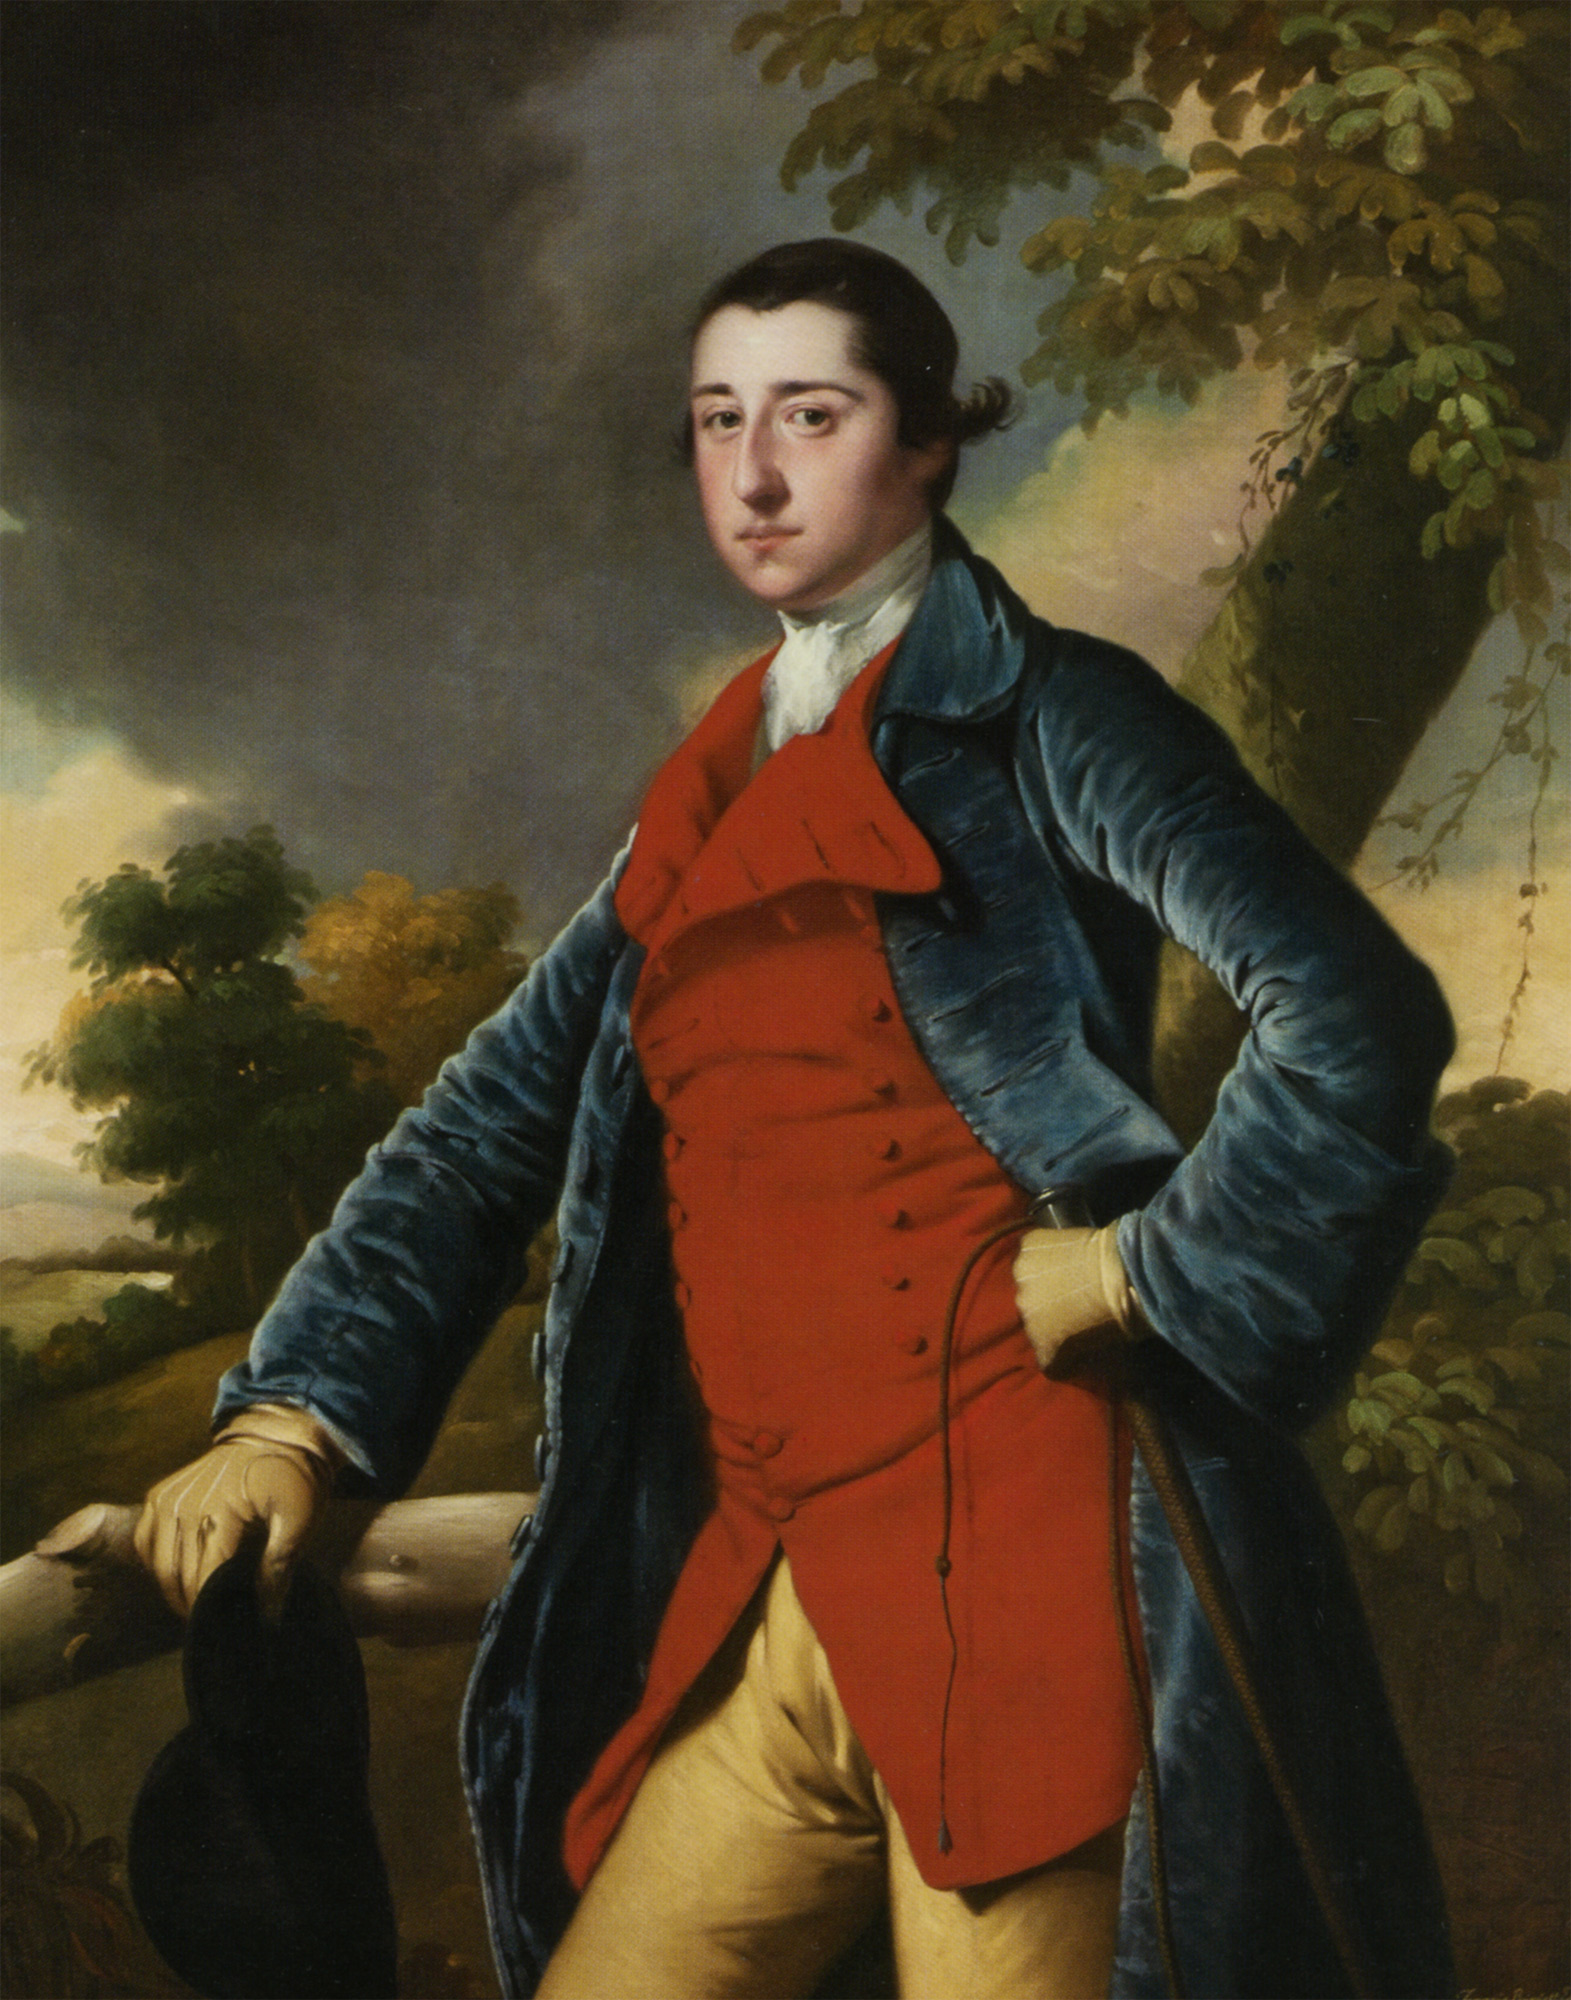Analyze the image in a comprehensive and detailed manner. The image depicts a striking portrait of a young man, poised confidently against a vibrant landscape. He is adorned in a rich blue velvet coat with structured shoulders and edged with detailed gold embroidery, suggesting a garment of high quality and fashion for the 18th century. Beneath the coat, a bright red waistcoat offers a bold contrast, paired with mustard yellow breeches, completing a typical yet luxurious ensemble of the period. The man's pose, with one hand gripping the brim of his black hat and another resting casually on a wooden fence, alongside his direct gaze, evokes a sense of direct engagement with the viewer. The setting features dynamic skies and lush greenery, which may imply his connection with the natural world or status. This detailed analysis reveals not just the fashion, but also the possible social status and personal attitudes of the figure depicted. 